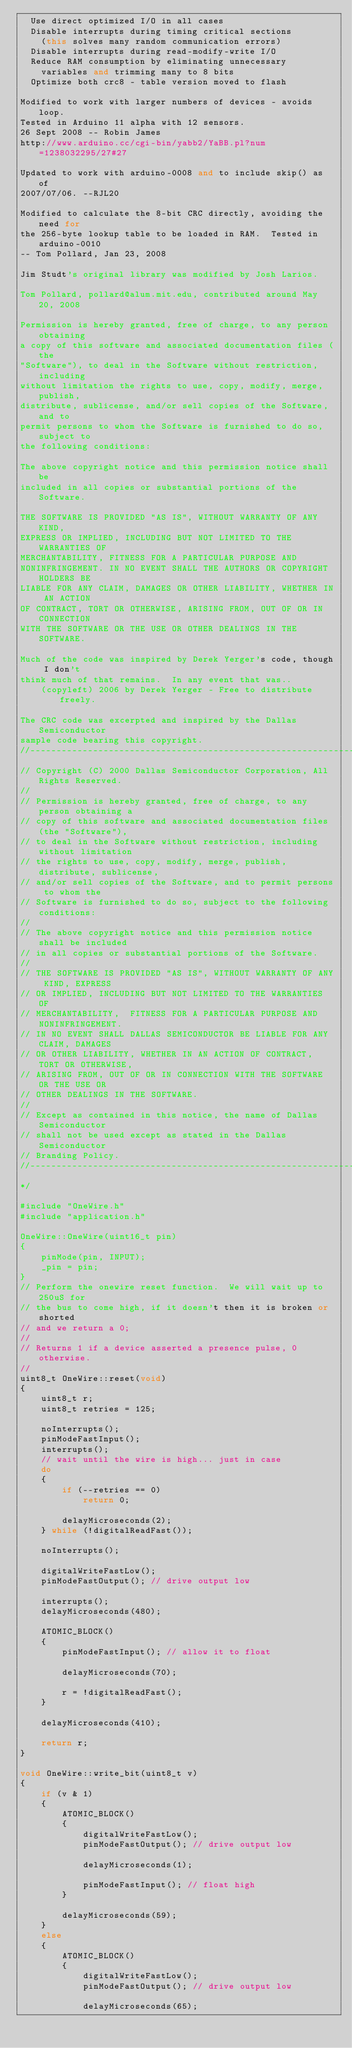Convert code to text. <code><loc_0><loc_0><loc_500><loc_500><_C++_>  Use direct optimized I/O in all cases
  Disable interrupts during timing critical sections
    (this solves many random communication errors)
  Disable interrupts during read-modify-write I/O
  Reduce RAM consumption by eliminating unnecessary
    variables and trimming many to 8 bits
  Optimize both crc8 - table version moved to flash

Modified to work with larger numbers of devices - avoids loop.
Tested in Arduino 11 alpha with 12 sensors.
26 Sept 2008 -- Robin James
http://www.arduino.cc/cgi-bin/yabb2/YaBB.pl?num=1238032295/27#27

Updated to work with arduino-0008 and to include skip() as of
2007/07/06. --RJL20

Modified to calculate the 8-bit CRC directly, avoiding the need for
the 256-byte lookup table to be loaded in RAM.  Tested in arduino-0010
-- Tom Pollard, Jan 23, 2008

Jim Studt's original library was modified by Josh Larios.

Tom Pollard, pollard@alum.mit.edu, contributed around May 20, 2008

Permission is hereby granted, free of charge, to any person obtaining
a copy of this software and associated documentation files (the
"Software"), to deal in the Software without restriction, including
without limitation the rights to use, copy, modify, merge, publish,
distribute, sublicense, and/or sell copies of the Software, and to
permit persons to whom the Software is furnished to do so, subject to
the following conditions:

The above copyright notice and this permission notice shall be
included in all copies or substantial portions of the Software.

THE SOFTWARE IS PROVIDED "AS IS", WITHOUT WARRANTY OF ANY KIND,
EXPRESS OR IMPLIED, INCLUDING BUT NOT LIMITED TO THE WARRANTIES OF
MERCHANTABILITY, FITNESS FOR A PARTICULAR PURPOSE AND
NONINFRINGEMENT. IN NO EVENT SHALL THE AUTHORS OR COPYRIGHT HOLDERS BE
LIABLE FOR ANY CLAIM, DAMAGES OR OTHER LIABILITY, WHETHER IN AN ACTION
OF CONTRACT, TORT OR OTHERWISE, ARISING FROM, OUT OF OR IN CONNECTION
WITH THE SOFTWARE OR THE USE OR OTHER DEALINGS IN THE SOFTWARE.

Much of the code was inspired by Derek Yerger's code, though I don't
think much of that remains.  In any event that was..
    (copyleft) 2006 by Derek Yerger - Free to distribute freely.

The CRC code was excerpted and inspired by the Dallas Semiconductor
sample code bearing this copyright.
//---------------------------------------------------------------------------
// Copyright (C) 2000 Dallas Semiconductor Corporation, All Rights Reserved.
//
// Permission is hereby granted, free of charge, to any person obtaining a
// copy of this software and associated documentation files (the "Software"),
// to deal in the Software without restriction, including without limitation
// the rights to use, copy, modify, merge, publish, distribute, sublicense,
// and/or sell copies of the Software, and to permit persons to whom the
// Software is furnished to do so, subject to the following conditions:
//
// The above copyright notice and this permission notice shall be included
// in all copies or substantial portions of the Software.
//
// THE SOFTWARE IS PROVIDED "AS IS", WITHOUT WARRANTY OF ANY KIND, EXPRESS
// OR IMPLIED, INCLUDING BUT NOT LIMITED TO THE WARRANTIES OF
// MERCHANTABILITY,  FITNESS FOR A PARTICULAR PURPOSE AND NONINFRINGEMENT.
// IN NO EVENT SHALL DALLAS SEMICONDUCTOR BE LIABLE FOR ANY CLAIM, DAMAGES
// OR OTHER LIABILITY, WHETHER IN AN ACTION OF CONTRACT, TORT OR OTHERWISE,
// ARISING FROM, OUT OF OR IN CONNECTION WITH THE SOFTWARE OR THE USE OR
// OTHER DEALINGS IN THE SOFTWARE.
//
// Except as contained in this notice, the name of Dallas Semiconductor
// shall not be used except as stated in the Dallas Semiconductor
// Branding Policy.
//--------------------------------------------------------------------------
*/

#include "OneWire.h"
#include "application.h"

OneWire::OneWire(uint16_t pin)
{
    pinMode(pin, INPUT);
    _pin = pin;
}
// Perform the onewire reset function.  We will wait up to 250uS for
// the bus to come high, if it doesn't then it is broken or shorted
// and we return a 0;
//
// Returns 1 if a device asserted a presence pulse, 0 otherwise.
//
uint8_t OneWire::reset(void)
{
    uint8_t r;
    uint8_t retries = 125;

    noInterrupts();
    pinModeFastInput();
    interrupts();
    // wait until the wire is high... just in case
    do
    {
        if (--retries == 0)
            return 0;

        delayMicroseconds(2);
    } while (!digitalReadFast());

    noInterrupts();

    digitalWriteFastLow();
    pinModeFastOutput(); // drive output low

    interrupts();
    delayMicroseconds(480);

    ATOMIC_BLOCK()
    {
        pinModeFastInput(); // allow it to float

        delayMicroseconds(70);

        r = !digitalReadFast();
    }

    delayMicroseconds(410);

    return r;
}

void OneWire::write_bit(uint8_t v)
{
    if (v & 1)
    {
        ATOMIC_BLOCK()
        {
            digitalWriteFastLow();
            pinModeFastOutput(); // drive output low

            delayMicroseconds(1);

            pinModeFastInput(); // float high
        }

        delayMicroseconds(59);
    }
    else
    {
        ATOMIC_BLOCK()
        {
            digitalWriteFastLow();
            pinModeFastOutput(); // drive output low

            delayMicroseconds(65);
</code> 